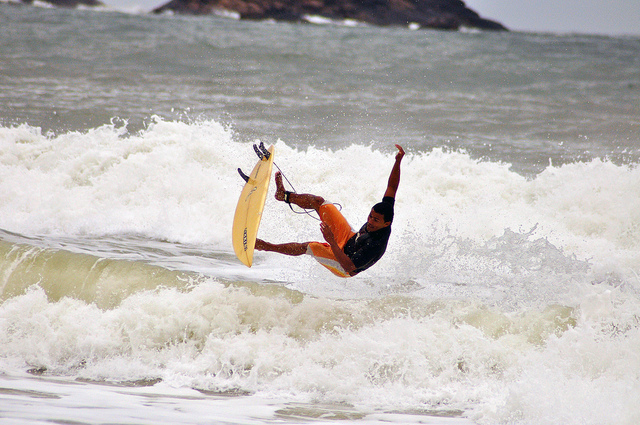Can you describe the setting of this surfing activity? The surfing is taking place in a rough, wavy sea with a cloudy background, suggesting challenging weather conditions which add an exciting dimension to the surfing experience.  Are there any indications of the time or season this might be? The overcast sky and the surfer's attire suggest it could be during a cooler season, or possibly a stormy day, as the surfer wears a bodysuit, typically used for additional warmth and protection. 